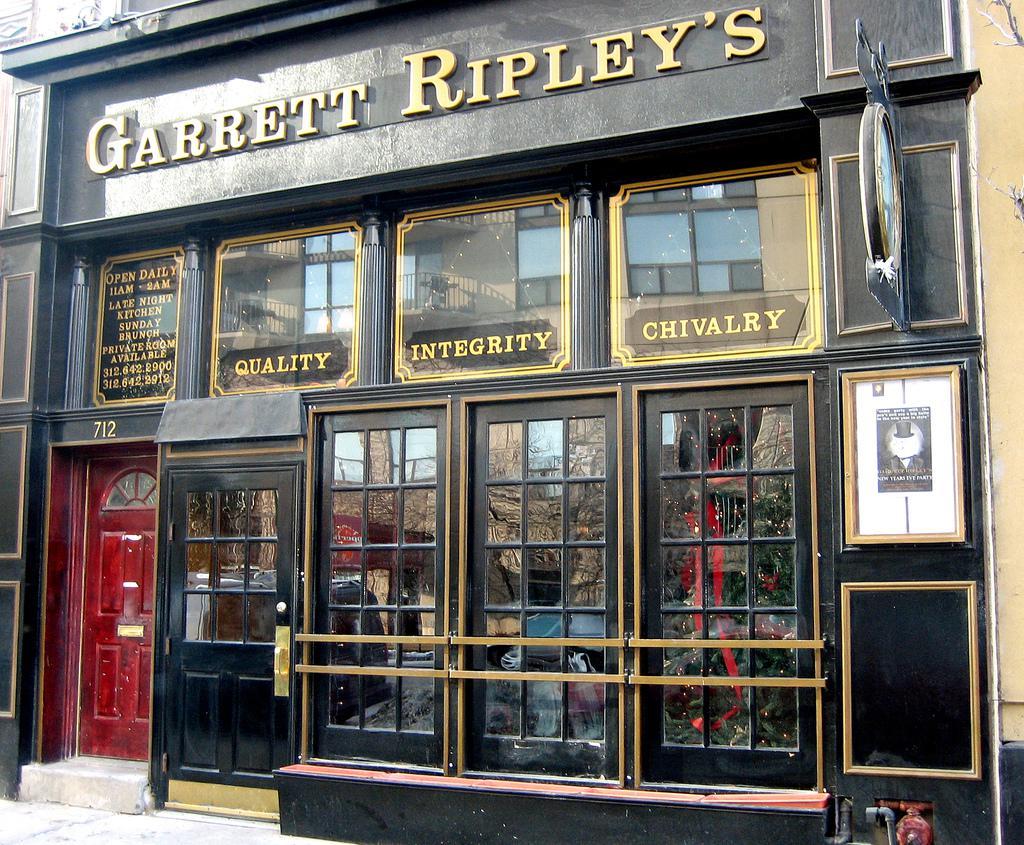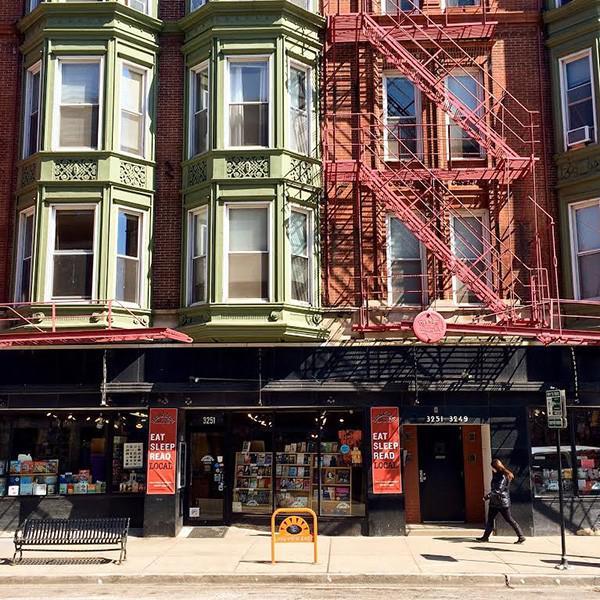The first image is the image on the left, the second image is the image on the right. Examine the images to the left and right. Is the description "A yellow sign sits on the sidewalk in the image on the right." accurate? Answer yes or no. Yes. The first image is the image on the left, the second image is the image on the right. Given the left and right images, does the statement "Both pictures show the inside of a bookstore." hold true? Answer yes or no. No. 